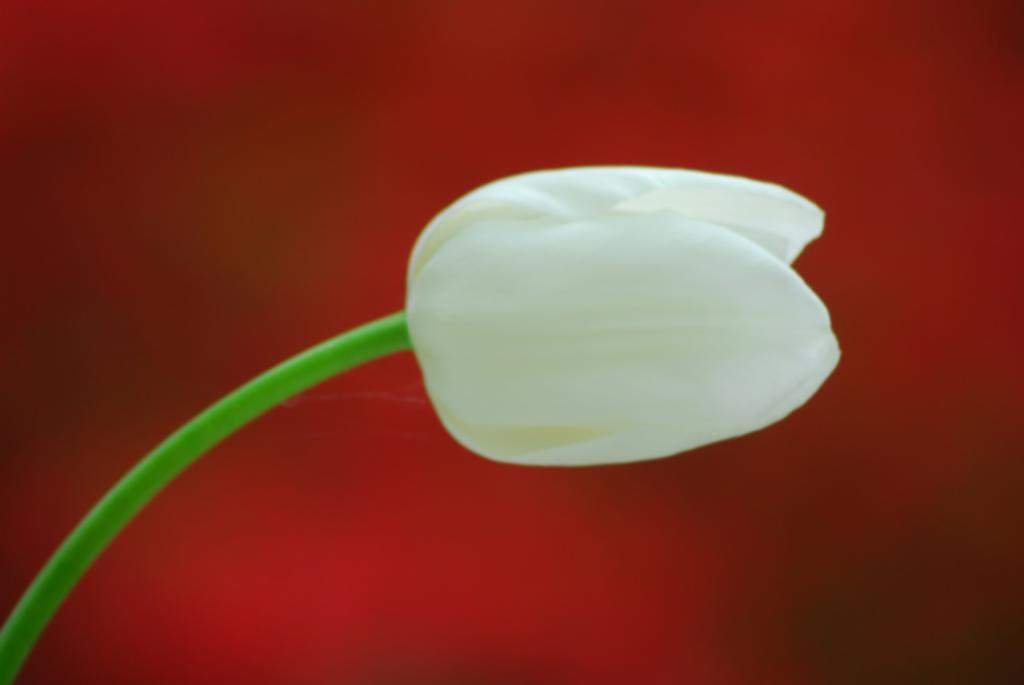What is the main subject of the image? There is a flower in the image. What color is the flower? The flower is white in color. Is there an umbrella protecting the flower from the rain in the image? There is no mention of rain or an umbrella in the image, and the image only shows a white flower. 